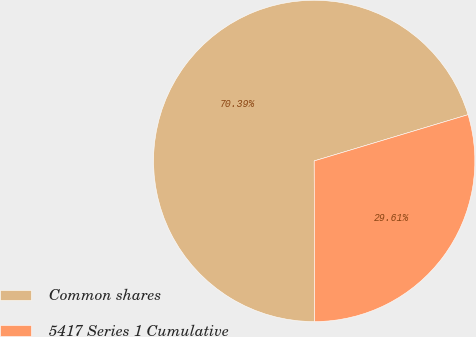Convert chart. <chart><loc_0><loc_0><loc_500><loc_500><pie_chart><fcel>Common shares<fcel>5417 Series 1 Cumulative<nl><fcel>70.39%<fcel>29.61%<nl></chart> 